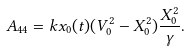Convert formula to latex. <formula><loc_0><loc_0><loc_500><loc_500>A _ { 4 4 } = k x _ { 0 } ( t ) ( V _ { 0 } ^ { 2 } - X _ { 0 } ^ { 2 } ) \frac { X _ { 0 } ^ { 2 } } { \gamma } .</formula> 